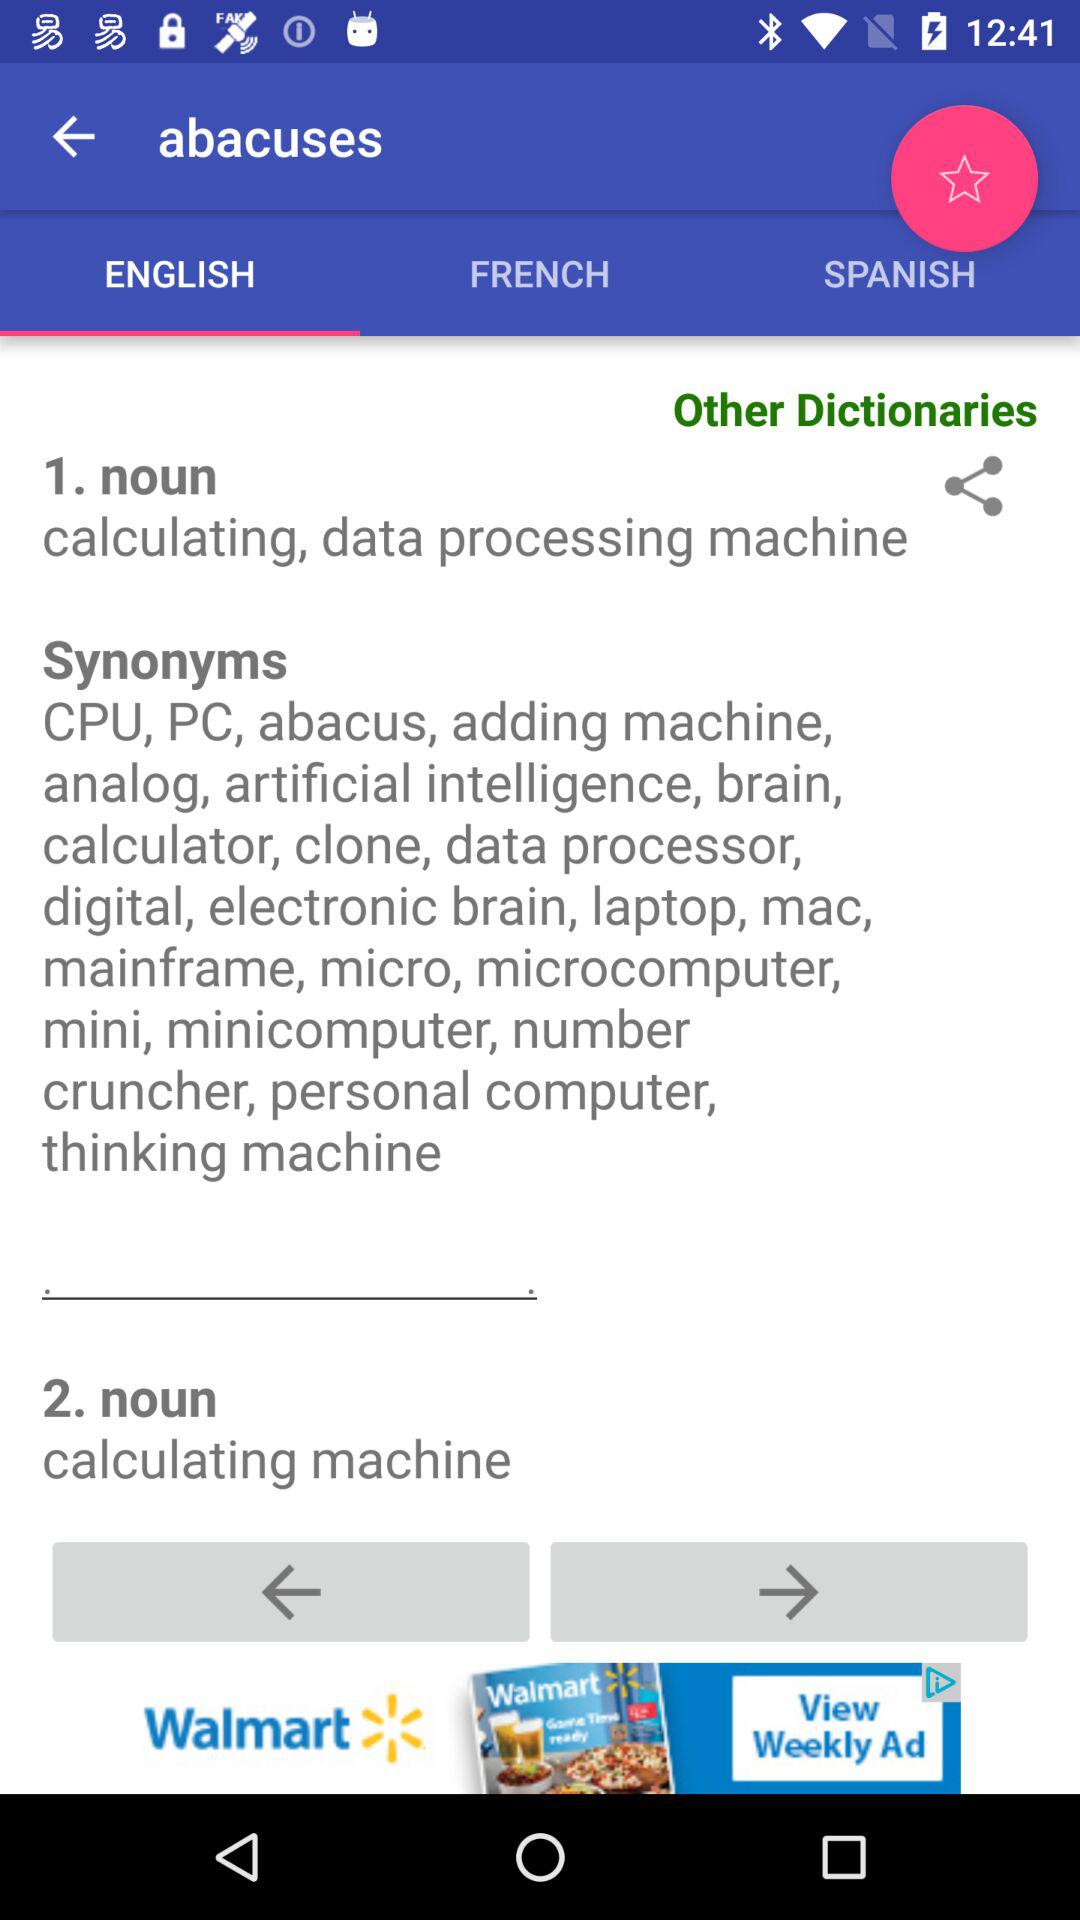What is the selected option? The selected option is "ENGLISH". 